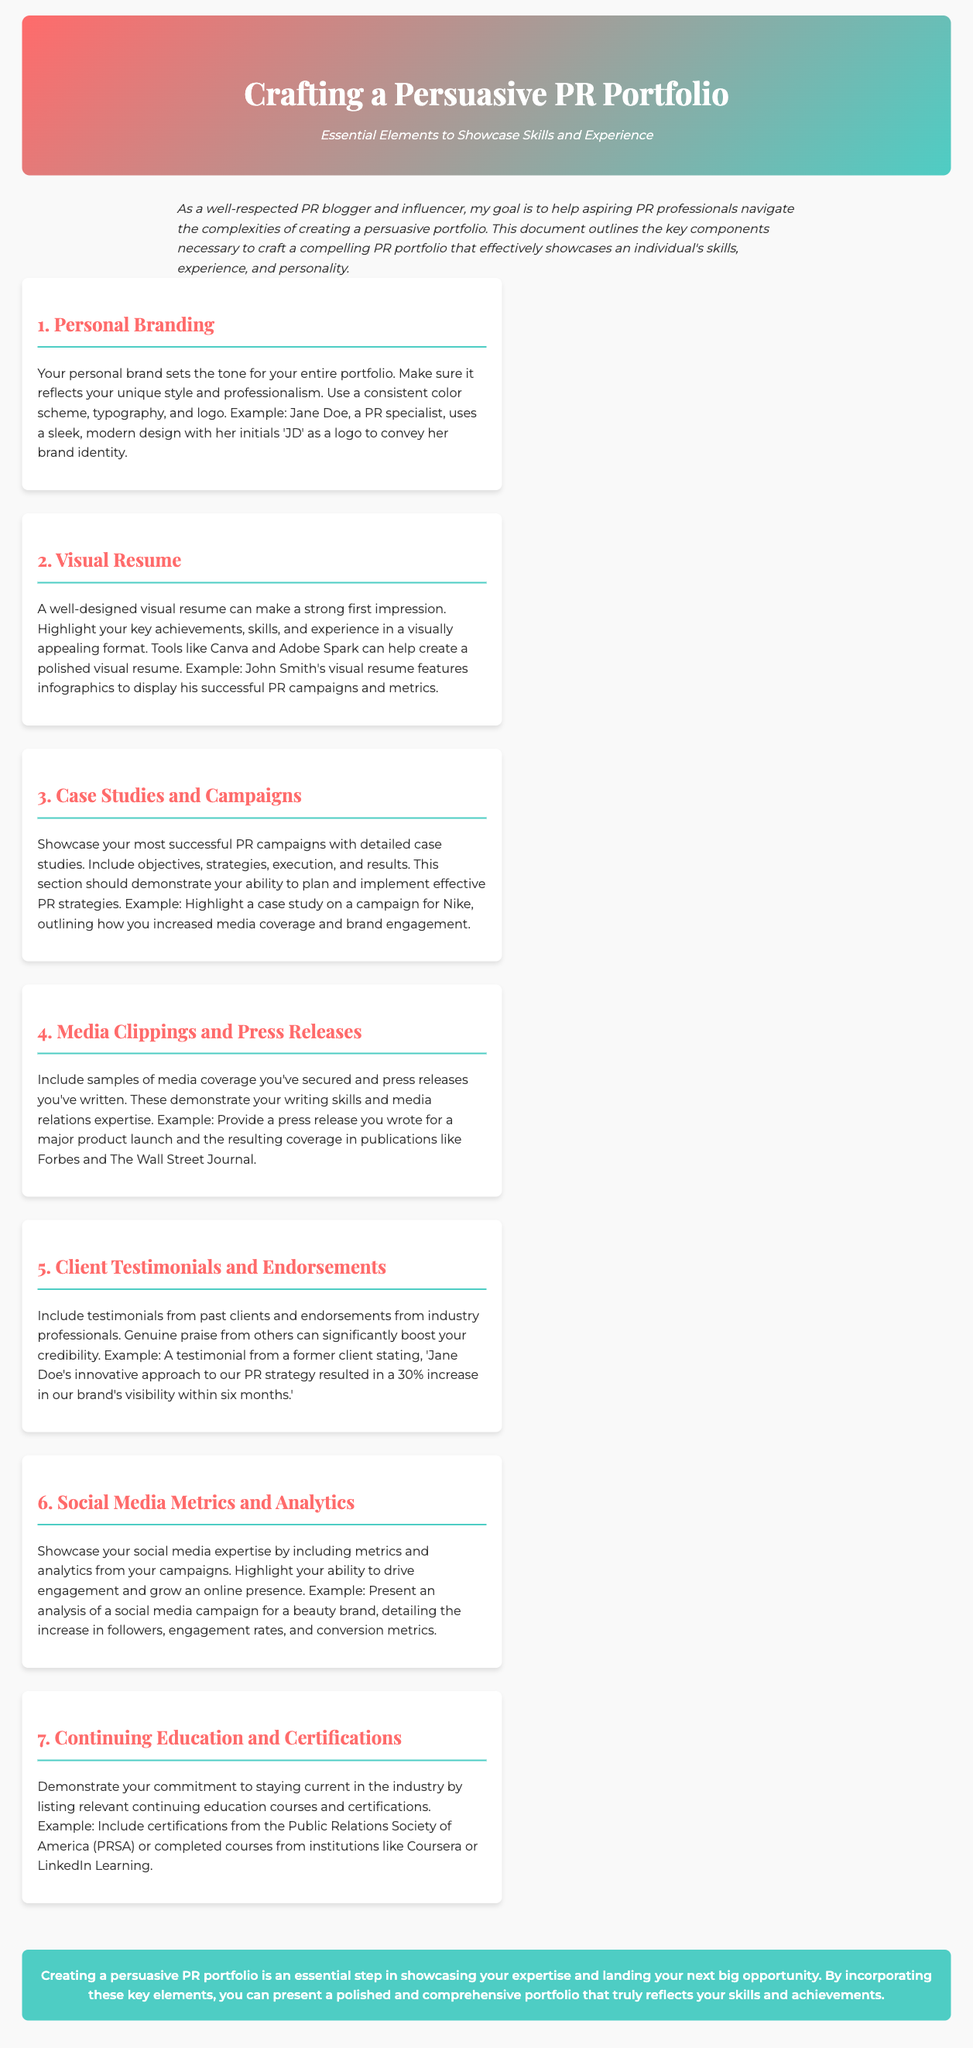What is the main goal of the document? The document outlines the essential elements for crafting a persuasive PR portfolio aimed at aspiring PR professionals.
Answer: Showcase skills and experience What is the first key element mentioned? The document lists key components necessary to craft a compelling PR portfolio, starting with personal branding.
Answer: Personal Branding How can a visual resume make an impression? It can highlight key achievements, skills, and experience in a visually appealing format.
Answer: Strong first impression What example is given for client testimonials? The document provides an example of a testimonial stating that a PR strategy resulted in a significant increase in brand visibility.
Answer: 30% increase Which organization should certifications be listed from? The document specifically mentions the Public Relations Society of America as a source for relevant certifications.
Answer: PRSA What type of metrics should be showcased? The document states that social media metrics and analytics should be included to demonstrate expertise in driving engagement.
Answer: Social media metrics How many sections are outlined in the document? The number of sections is indicated as there are seven individual key components highlighted.
Answer: Seven What design tool is recommended for creating a visual resume? The document suggests using tools to create visually appealing resumes, specifically mentioning Canva and Adobe Spark.
Answer: Canva What is the ultimate goal of creating a persuasive PR portfolio? The conclusion emphasizes the importance of reflecting skills and achievements to secure opportunities.
Answer: Landing opportunities 